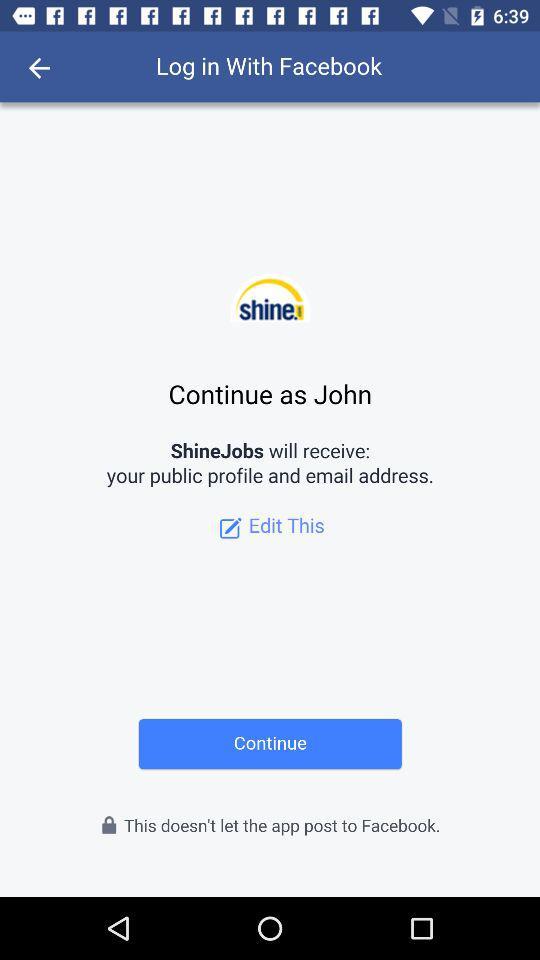Which email address will "ShineJobs" have access to?
When the provided information is insufficient, respond with <no answer>. <no answer> 